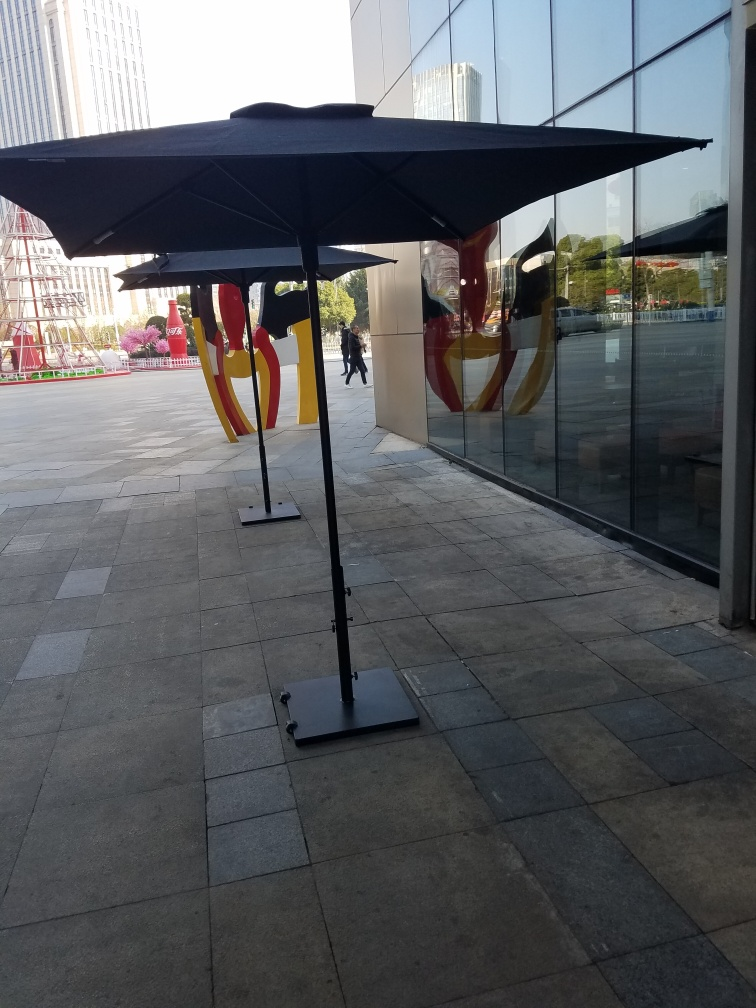Can you describe what elements in this image contribute to its urban feel? The image exudes an urban feel primarily through its setting in what appears to be a bustling city area with modern buildings reflecting sunlight. The presence of structured, geometric lines from the pavement tiles, the sleek, reflective glass façade, and even the contemporary design of the umbrellas and their stands, all contribute to a modern, metropolitan vibe. 